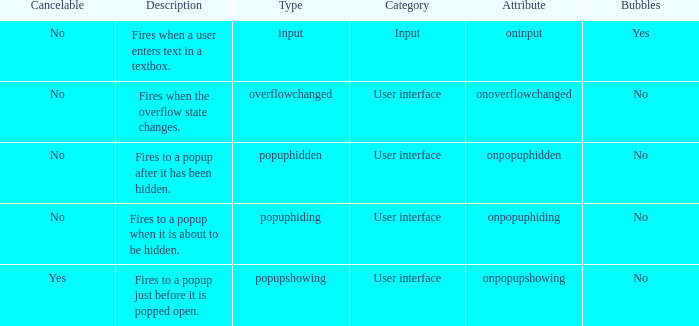Can you give me this table as a dict? {'header': ['Cancelable', 'Description', 'Type', 'Category', 'Attribute', 'Bubbles'], 'rows': [['No', 'Fires when a user enters text in a textbox.', 'input', 'Input', 'oninput', 'Yes'], ['No', 'Fires when the overflow state changes.', 'overflowchanged', 'User interface', 'onoverflowchanged', 'No'], ['No', 'Fires to a popup after it has been hidden.', 'popuphidden', 'User interface', 'onpopuphidden', 'No'], ['No', 'Fires to a popup when it is about to be hidden.', 'popuphiding', 'User interface', 'onpopuphiding', 'No'], ['Yes', 'Fires to a popup just before it is popped open.', 'popupshowing', 'User interface', 'onpopupshowing', 'No']]} What's the type with description being fires when the overflow state changes. Overflowchanged. 